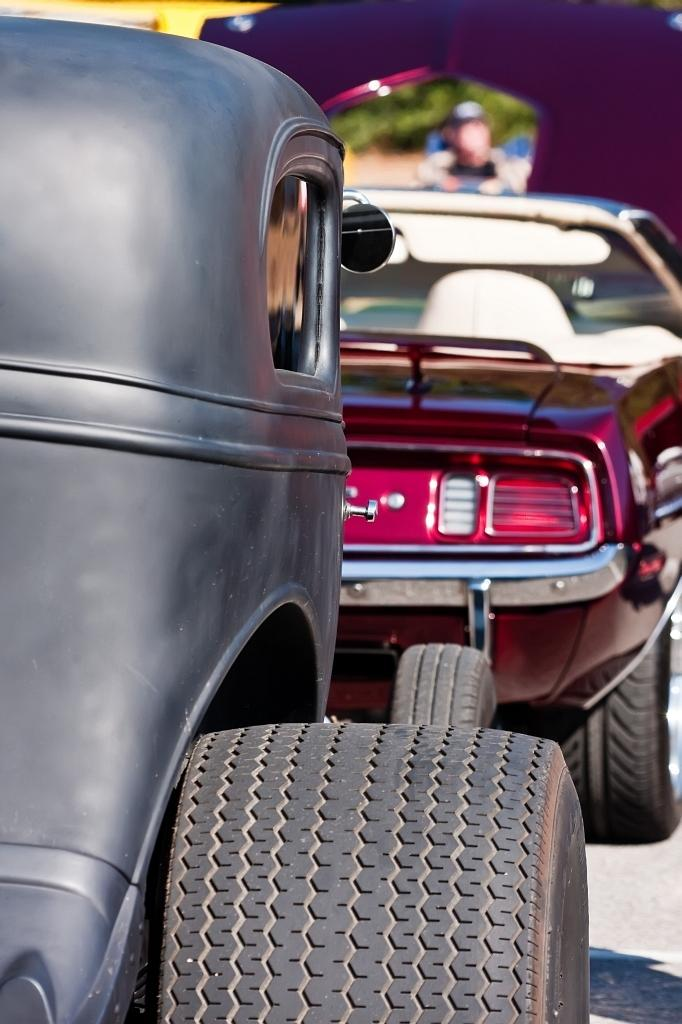What is the main subject of the image? The main subject of the image is two vehicles in the center. Can you describe the background of the image? The background of the image is blurred. How many fingers can be seen pointing at the vehicles in the image? There are no fingers visible in the image, as it only features two vehicles and a blurred background. 